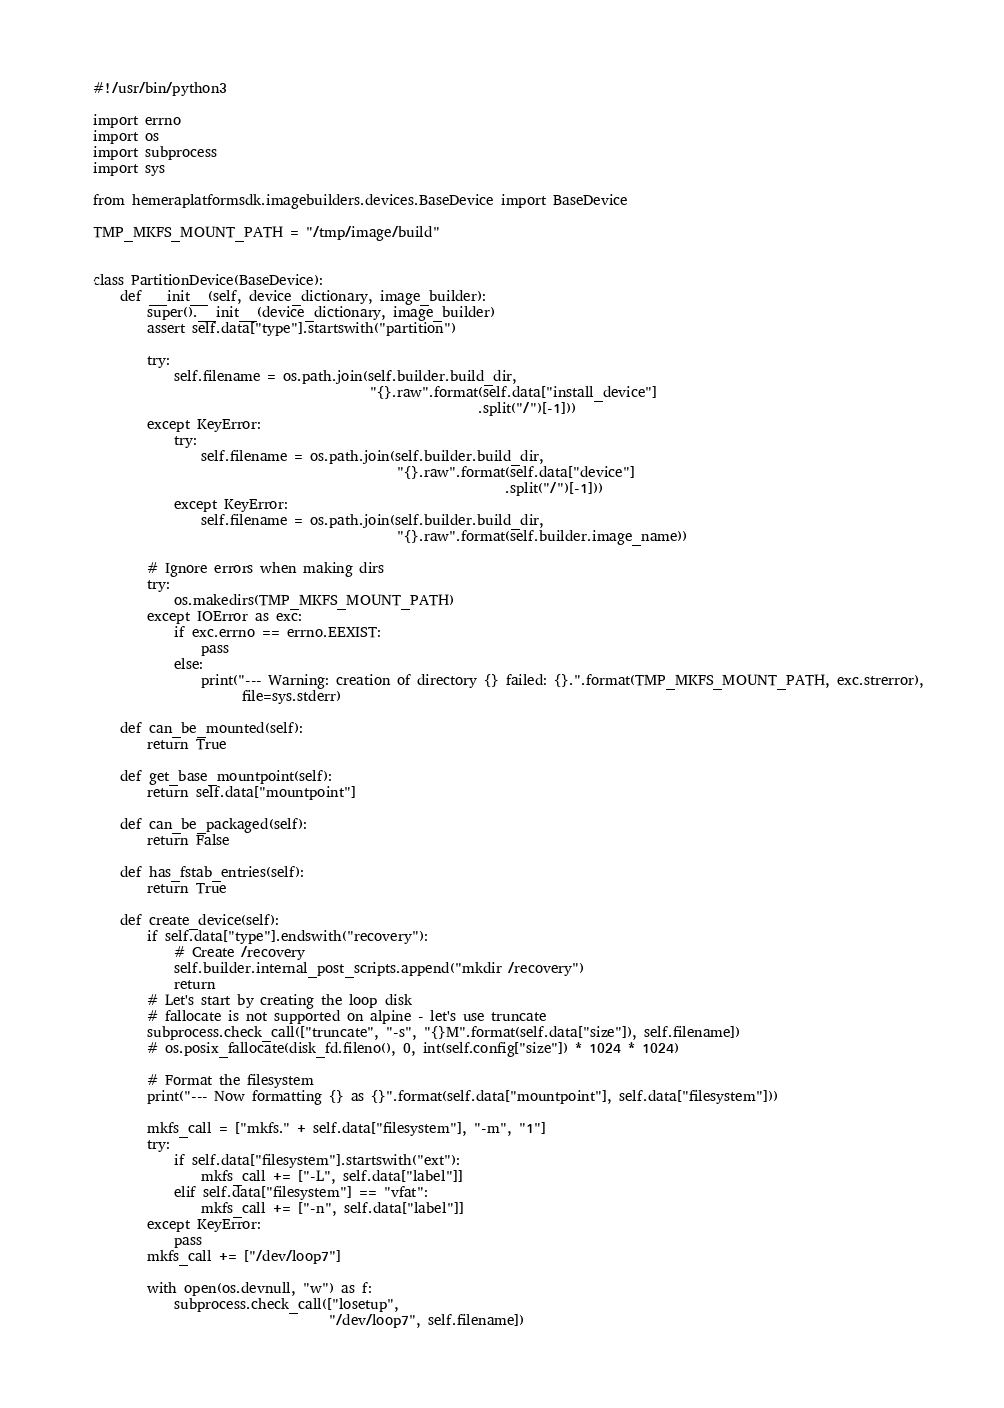Convert code to text. <code><loc_0><loc_0><loc_500><loc_500><_Python_>#!/usr/bin/python3

import errno
import os
import subprocess
import sys

from hemeraplatformsdk.imagebuilders.devices.BaseDevice import BaseDevice

TMP_MKFS_MOUNT_PATH = "/tmp/image/build"


class PartitionDevice(BaseDevice):
    def __init__(self, device_dictionary, image_builder):
        super().__init__(device_dictionary, image_builder)
        assert self.data["type"].startswith("partition")

        try:
            self.filename = os.path.join(self.builder.build_dir,
                                         "{}.raw".format(self.data["install_device"]
                                                         .split("/")[-1]))
        except KeyError:
            try:
                self.filename = os.path.join(self.builder.build_dir,
                                             "{}.raw".format(self.data["device"]
                                                             .split("/")[-1]))
            except KeyError:
                self.filename = os.path.join(self.builder.build_dir,
                                             "{}.raw".format(self.builder.image_name))

        # Ignore errors when making dirs
        try:
            os.makedirs(TMP_MKFS_MOUNT_PATH)
        except IOError as exc:
            if exc.errno == errno.EEXIST:
                pass
            else:
                print("--- Warning: creation of directory {} failed: {}.".format(TMP_MKFS_MOUNT_PATH, exc.strerror),
                      file=sys.stderr)

    def can_be_mounted(self):
        return True

    def get_base_mountpoint(self):
        return self.data["mountpoint"]

    def can_be_packaged(self):
        return False

    def has_fstab_entries(self):
        return True

    def create_device(self):
        if self.data["type"].endswith("recovery"):
            # Create /recovery
            self.builder.internal_post_scripts.append("mkdir /recovery")
            return
        # Let's start by creating the loop disk
        # fallocate is not supported on alpine - let's use truncate
        subprocess.check_call(["truncate", "-s", "{}M".format(self.data["size"]), self.filename])
        # os.posix_fallocate(disk_fd.fileno(), 0, int(self.config["size"]) * 1024 * 1024)

        # Format the filesystem
        print("--- Now formatting {} as {}".format(self.data["mountpoint"], self.data["filesystem"]))

        mkfs_call = ["mkfs." + self.data["filesystem"], "-m", "1"]
        try:
            if self.data["filesystem"].startswith("ext"):
                mkfs_call += ["-L", self.data["label"]]
            elif self.data["filesystem"] == "vfat":
                mkfs_call += ["-n", self.data["label"]]
        except KeyError:
            pass
        mkfs_call += ["/dev/loop7"]

        with open(os.devnull, "w") as f:
            subprocess.check_call(["losetup",
                                   "/dev/loop7", self.filename])</code> 